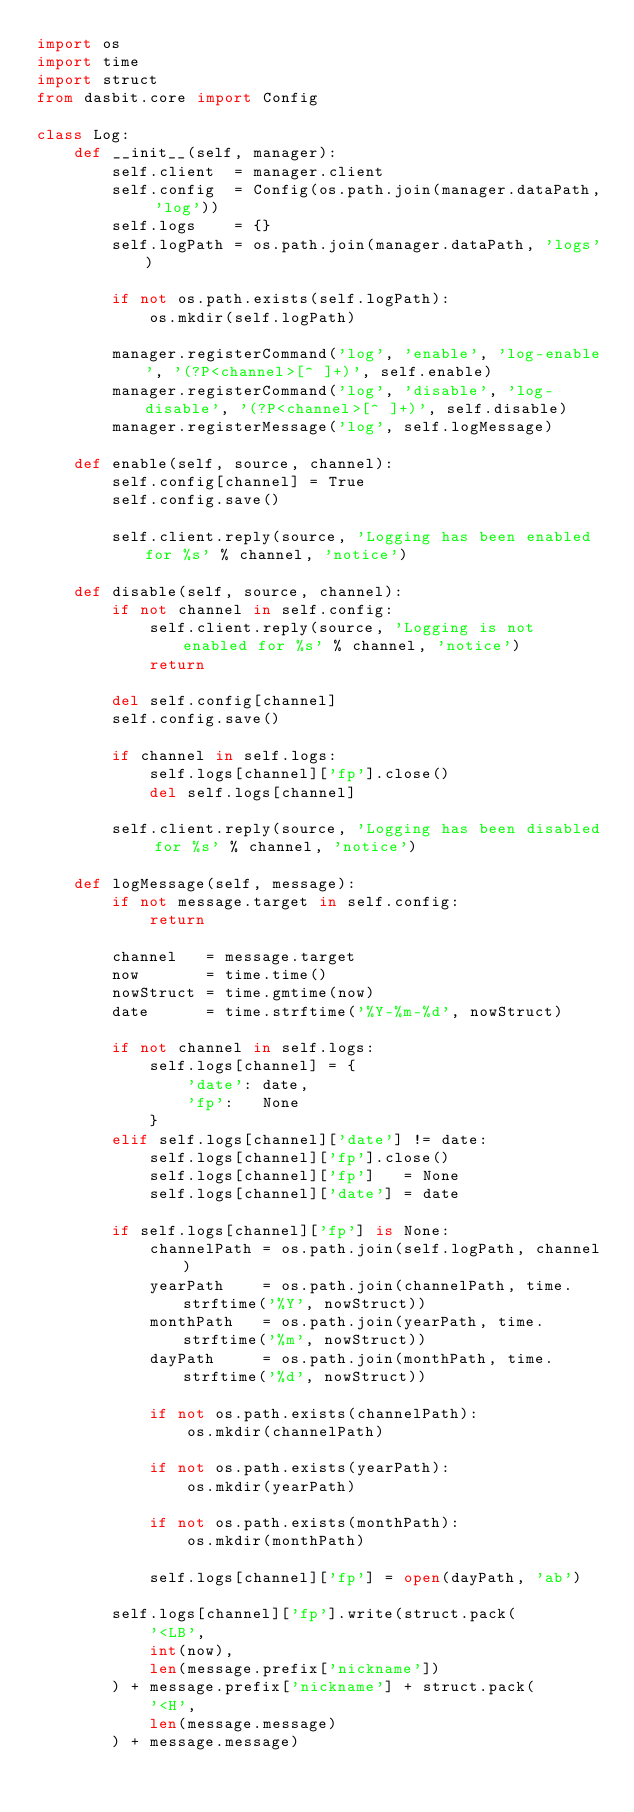<code> <loc_0><loc_0><loc_500><loc_500><_Python_>import os
import time
import struct
from dasbit.core import Config

class Log:
    def __init__(self, manager):
        self.client  = manager.client
        self.config  = Config(os.path.join(manager.dataPath, 'log'))
        self.logs    = {}
        self.logPath = os.path.join(manager.dataPath, 'logs')

        if not os.path.exists(self.logPath):
            os.mkdir(self.logPath)

        manager.registerCommand('log', 'enable', 'log-enable', '(?P<channel>[^ ]+)', self.enable)
        manager.registerCommand('log', 'disable', 'log-disable', '(?P<channel>[^ ]+)', self.disable)
        manager.registerMessage('log', self.logMessage)

    def enable(self, source, channel):
        self.config[channel] = True
        self.config.save()

        self.client.reply(source, 'Logging has been enabled for %s' % channel, 'notice')

    def disable(self, source, channel):
        if not channel in self.config:
            self.client.reply(source, 'Logging is not enabled for %s' % channel, 'notice')
            return

        del self.config[channel]
        self.config.save()

        if channel in self.logs:
            self.logs[channel]['fp'].close()
            del self.logs[channel]

        self.client.reply(source, 'Logging has been disabled for %s' % channel, 'notice')

    def logMessage(self, message):
        if not message.target in self.config:
            return

        channel   = message.target
        now       = time.time()
        nowStruct = time.gmtime(now)
        date      = time.strftime('%Y-%m-%d', nowStruct)

        if not channel in self.logs:
            self.logs[channel] = {
                'date': date,
                'fp':   None
            }
        elif self.logs[channel]['date'] != date:
            self.logs[channel]['fp'].close()
            self.logs[channel]['fp']   = None
            self.logs[channel]['date'] = date

        if self.logs[channel]['fp'] is None:
            channelPath = os.path.join(self.logPath, channel)
            yearPath    = os.path.join(channelPath, time.strftime('%Y', nowStruct))
            monthPath   = os.path.join(yearPath, time.strftime('%m', nowStruct))
            dayPath     = os.path.join(monthPath, time.strftime('%d', nowStruct))

            if not os.path.exists(channelPath):
                os.mkdir(channelPath)

            if not os.path.exists(yearPath):
                os.mkdir(yearPath)

            if not os.path.exists(monthPath):
                os.mkdir(monthPath)

            self.logs[channel]['fp'] = open(dayPath, 'ab')

        self.logs[channel]['fp'].write(struct.pack(
            '<LB',
            int(now),
            len(message.prefix['nickname'])
        ) + message.prefix['nickname'] + struct.pack(
            '<H',
            len(message.message)
        ) + message.message)
</code> 